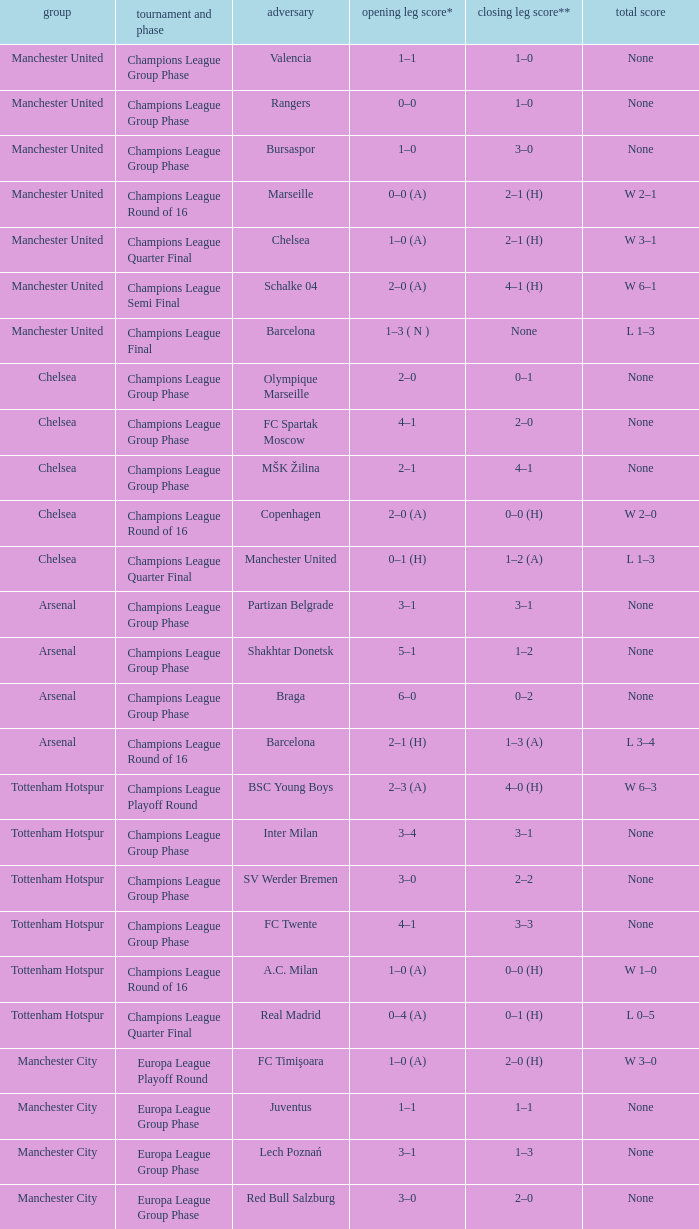What was the score between Marseille and Manchester United on the second leg of the Champions League Round of 16? 2–1 (H). 